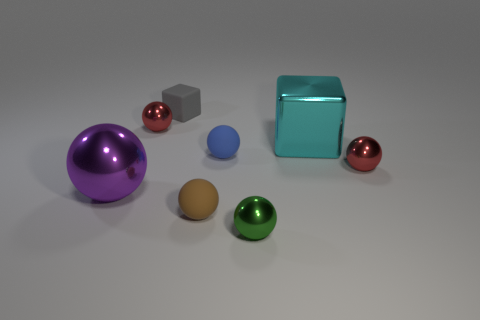What shape is the small green thing that is the same material as the large cyan cube?
Keep it short and to the point. Sphere. The purple ball that is the same material as the small green thing is what size?
Make the answer very short. Large. Is there another rubber ball of the same color as the big ball?
Offer a very short reply. No. There is a big metallic object on the left side of the small gray cube; does it have the same color as the small thing that is on the left side of the gray rubber cube?
Make the answer very short. No. Is there a purple ball that has the same material as the gray object?
Your response must be concise. No. What is the color of the small matte block?
Offer a very short reply. Gray. There is a red shiny thing that is to the right of the gray block that is behind the tiny red metallic ball in front of the blue rubber sphere; how big is it?
Ensure brevity in your answer.  Small. What number of other things are the same shape as the tiny brown matte thing?
Your response must be concise. 5. There is a thing that is behind the blue matte sphere and right of the small gray matte cube; what color is it?
Offer a terse response. Cyan. Is the color of the small metal ball that is to the left of the green shiny object the same as the large block?
Provide a succinct answer. No. 